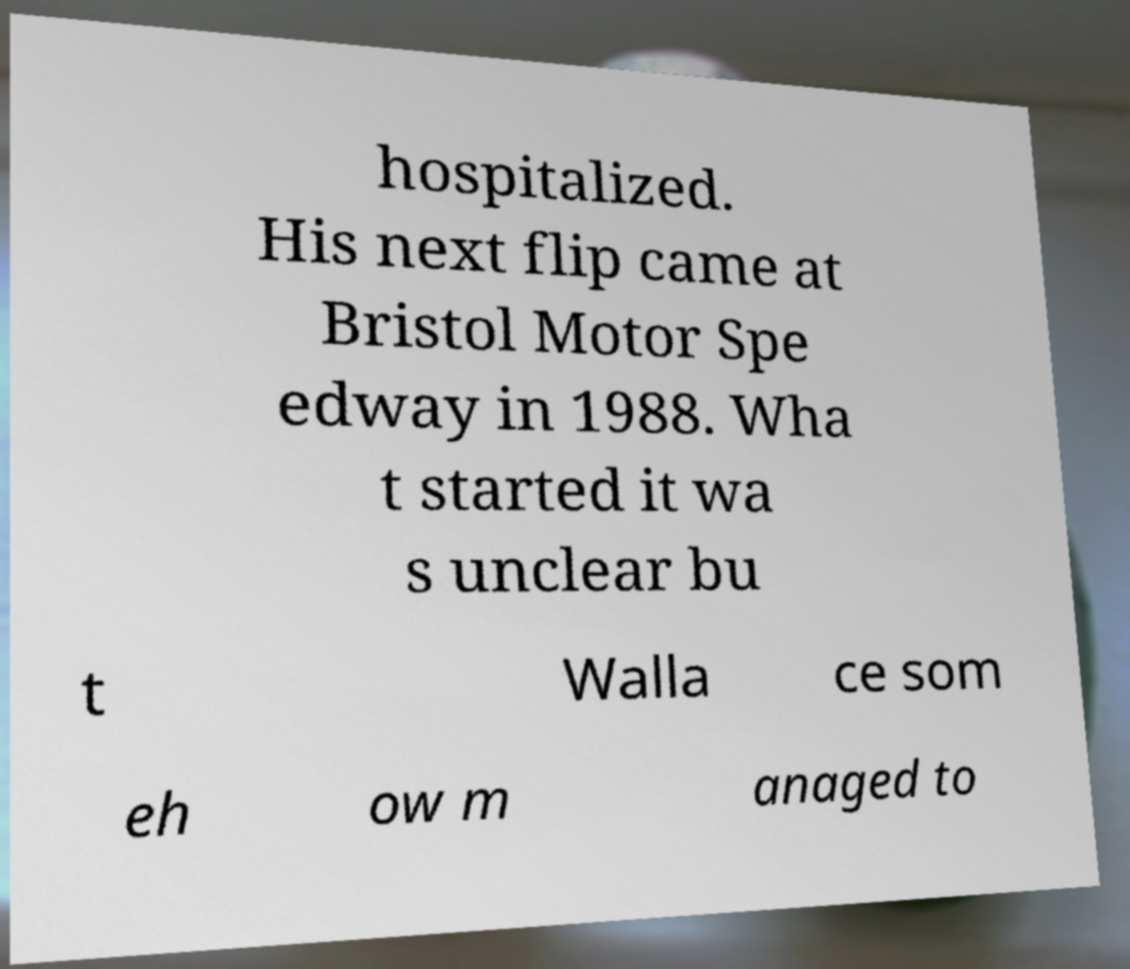What messages or text are displayed in this image? I need them in a readable, typed format. hospitalized. His next flip came at Bristol Motor Spe edway in 1988. Wha t started it wa s unclear bu t Walla ce som eh ow m anaged to 